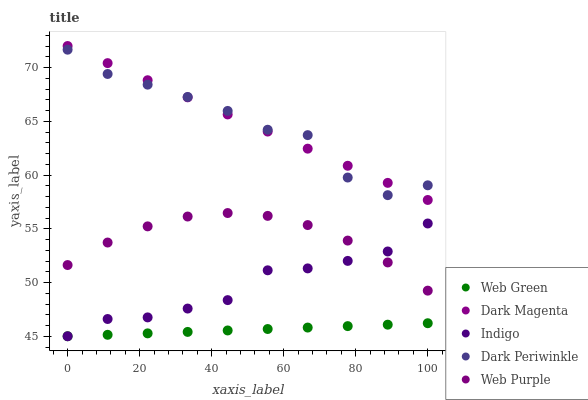Does Web Green have the minimum area under the curve?
Answer yes or no. Yes. Does Dark Magenta have the maximum area under the curve?
Answer yes or no. Yes. Does Indigo have the minimum area under the curve?
Answer yes or no. No. Does Indigo have the maximum area under the curve?
Answer yes or no. No. Is Web Green the smoothest?
Answer yes or no. Yes. Is Dark Periwinkle the roughest?
Answer yes or no. Yes. Is Indigo the smoothest?
Answer yes or no. No. Is Indigo the roughest?
Answer yes or no. No. Does Indigo have the lowest value?
Answer yes or no. Yes. Does Dark Magenta have the lowest value?
Answer yes or no. No. Does Dark Magenta have the highest value?
Answer yes or no. Yes. Does Indigo have the highest value?
Answer yes or no. No. Is Web Green less than Dark Periwinkle?
Answer yes or no. Yes. Is Dark Magenta greater than Indigo?
Answer yes or no. Yes. Does Indigo intersect Web Purple?
Answer yes or no. Yes. Is Indigo less than Web Purple?
Answer yes or no. No. Is Indigo greater than Web Purple?
Answer yes or no. No. Does Web Green intersect Dark Periwinkle?
Answer yes or no. No. 